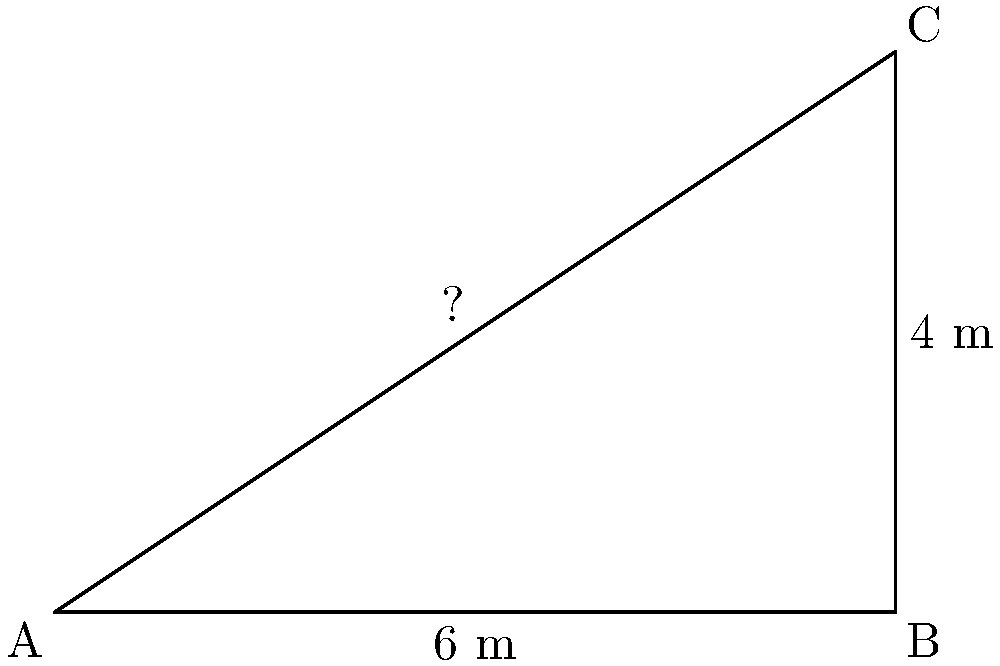In designing a new recording studio for doo-wop groups, you're working on a right-angled corner. The studio's width is 6 meters, and its depth is 4 meters. Using the Pythagorean theorem, calculate the diagonal length from one corner to the opposite corner. How might this diagonal measurement be relevant when setting up microphones or managing acoustic properties for recording doo-wop harmonies? Let's approach this step-by-step:

1) We're dealing with a right-angled triangle, where:
   - The width (AB) is 6 meters
   - The depth (BC) is 4 meters
   - We need to find the diagonal (AC)

2) The Pythagorean theorem states that in a right-angled triangle:
   $a^2 + b^2 = c^2$
   where c is the length of the hypotenuse (our diagonal)

3) Let's plug in our known values:
   $6^2 + 4^2 = c^2$

4) Simplify:
   $36 + 16 = c^2$
   $52 = c^2$

5) To find c, we take the square root of both sides:
   $c = \sqrt{52}$

6) Simplify the square root:
   $c = 2\sqrt{13} \approx 7.21$ meters

This diagonal measurement is crucial for several reasons:

a) Microphone placement: Knowing the maximum distance in the room helps in positioning microphones to capture the best blend of voices in doo-wop harmonies.

b) Acoustic treatment: The diagonal length influences standing waves and room modes, which are critical for achieving the warm, reverberant sound characteristic of doo-wop recordings.

c) Equipment setup: This measurement aids in planning the layout of recording equipment, ensuring optimal use of space while maintaining proper distances for sound isolation.

d) Reverb time calculation: The room's dimensions, including the diagonal, are used to calculate reverb times, which is essential for capturing the signature echo-chamber effect often used in doo-wop.
Answer: $2\sqrt{13}$ meters or approximately 7.21 meters 